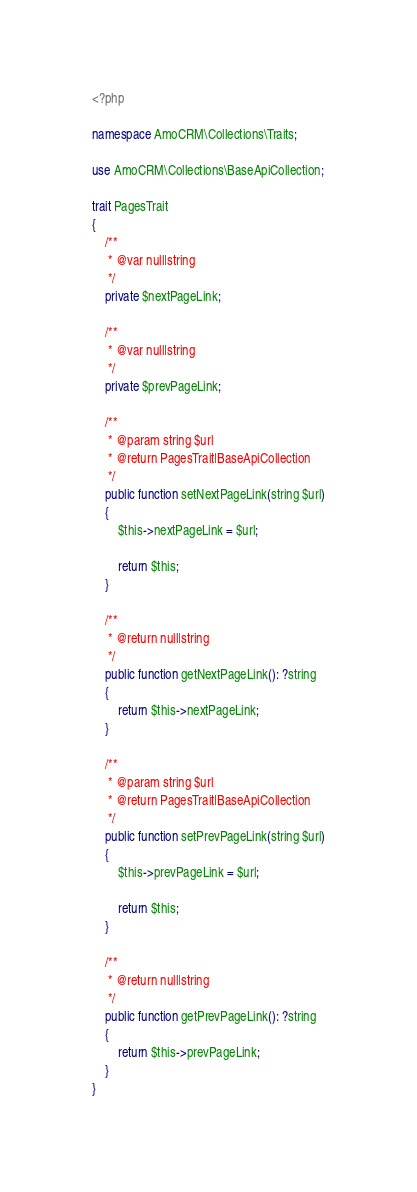Convert code to text. <code><loc_0><loc_0><loc_500><loc_500><_PHP_><?php

namespace AmoCRM\Collections\Traits;

use AmoCRM\Collections\BaseApiCollection;

trait PagesTrait
{
    /**
     * @var null|string
     */
    private $nextPageLink;

    /**
     * @var null|string
     */
    private $prevPageLink;

    /**
     * @param string $url
     * @return PagesTrait|BaseApiCollection
     */
    public function setNextPageLink(string $url)
    {
        $this->nextPageLink = $url;

        return $this;
    }

    /**
     * @return null|string
     */
    public function getNextPageLink(): ?string
    {
        return $this->nextPageLink;
    }

    /**
     * @param string $url
     * @return PagesTrait|BaseApiCollection
     */
    public function setPrevPageLink(string $url)
    {
        $this->prevPageLink = $url;

        return $this;
    }

    /**
     * @return null|string
     */
    public function getPrevPageLink(): ?string
    {
        return $this->prevPageLink;
    }
}
</code> 